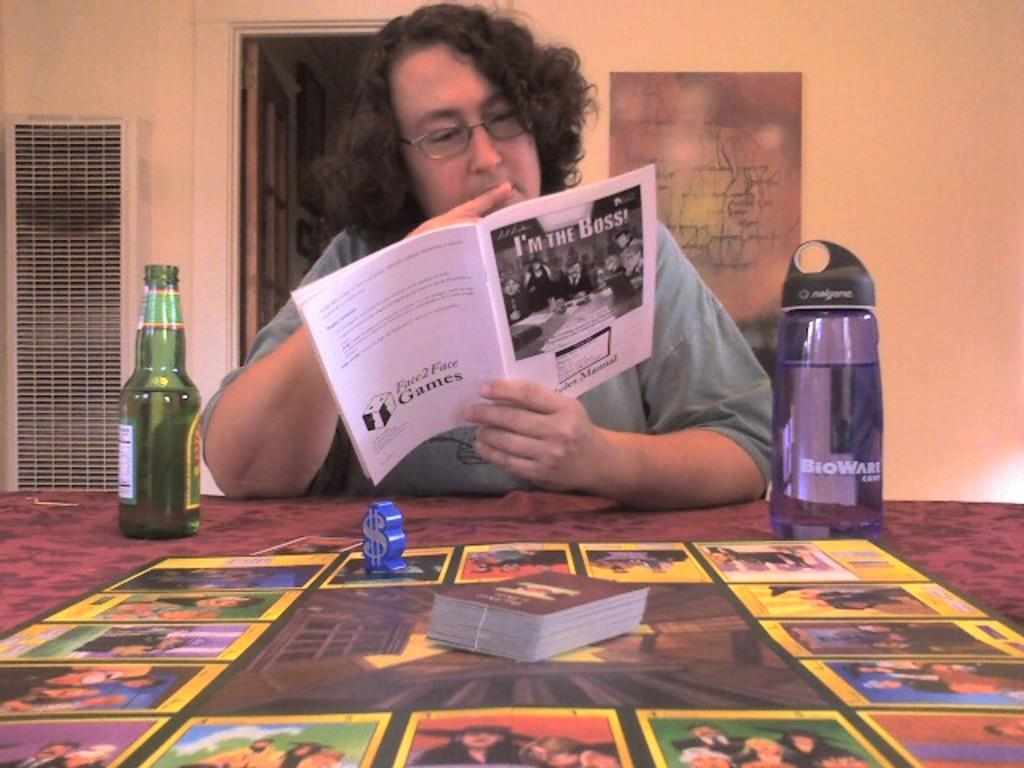<image>
Provide a brief description of the given image. A man with a beer, reading the instructions for the game "I'm the Boss." 